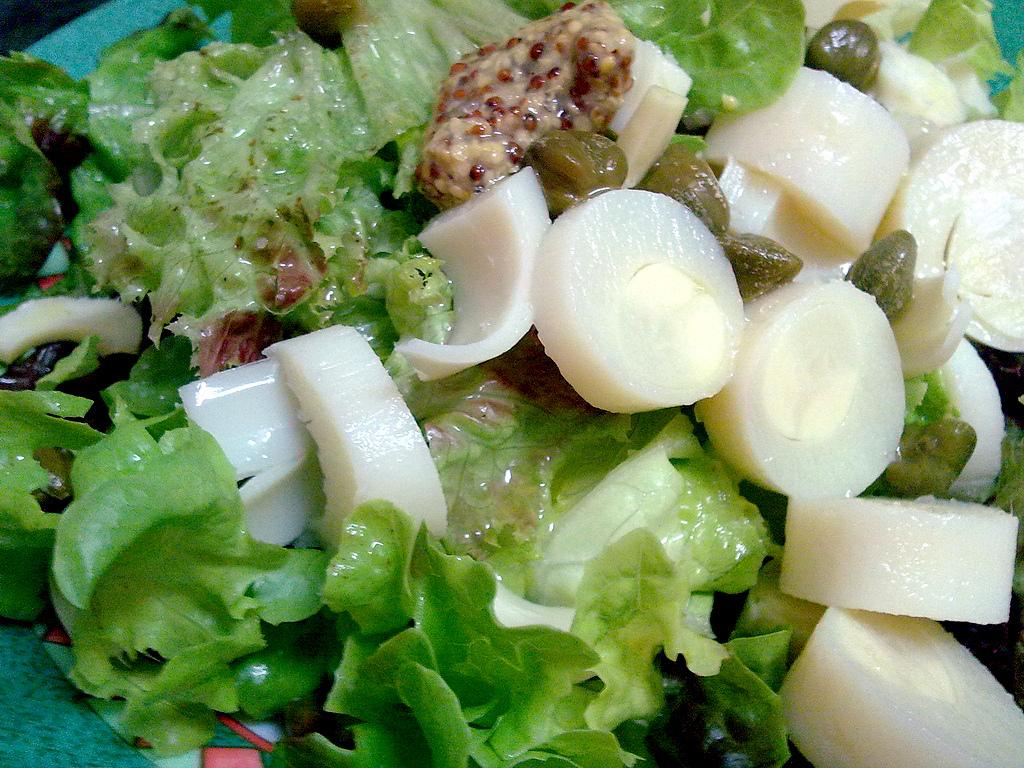What type of salad is visible in the image? There is lettuce salad in the image. What other types of vegetables can be seen in the image? There are other vegetables in the image, but their specific types are not mentioned. Is there a snail crawling on the lettuce in the image? There is no mention of a snail or any other living organisms in the image, so it cannot be determined from the facts provided. 